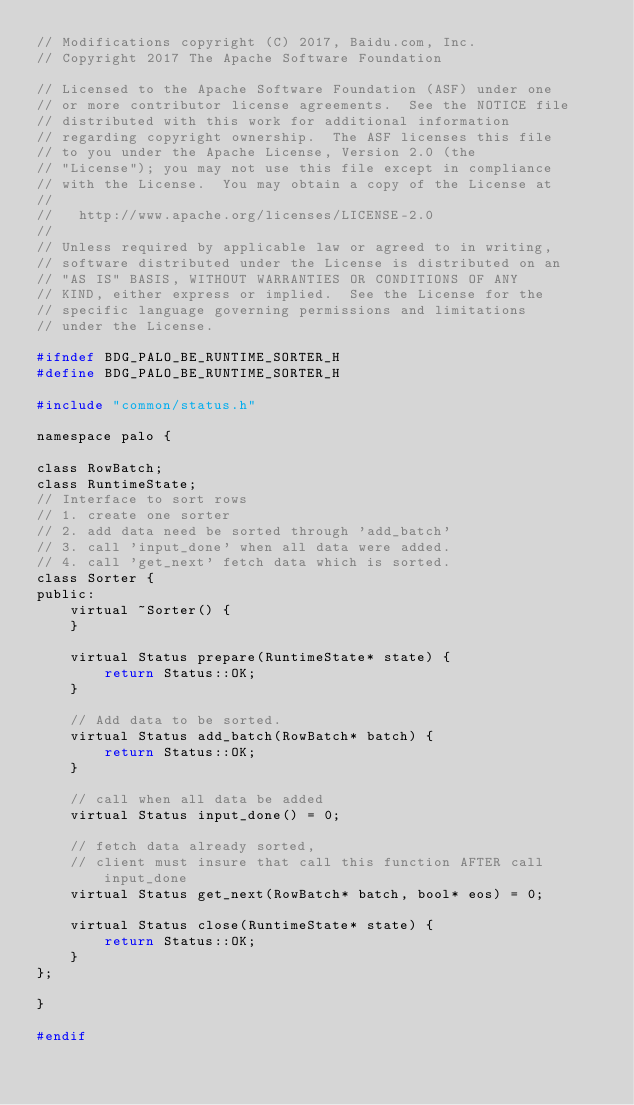<code> <loc_0><loc_0><loc_500><loc_500><_C_>// Modifications copyright (C) 2017, Baidu.com, Inc.
// Copyright 2017 The Apache Software Foundation

// Licensed to the Apache Software Foundation (ASF) under one
// or more contributor license agreements.  See the NOTICE file
// distributed with this work for additional information
// regarding copyright ownership.  The ASF licenses this file
// to you under the Apache License, Version 2.0 (the
// "License"); you may not use this file except in compliance
// with the License.  You may obtain a copy of the License at
//
//   http://www.apache.org/licenses/LICENSE-2.0
//
// Unless required by applicable law or agreed to in writing,
// software distributed under the License is distributed on an
// "AS IS" BASIS, WITHOUT WARRANTIES OR CONDITIONS OF ANY
// KIND, either express or implied.  See the License for the
// specific language governing permissions and limitations
// under the License.

#ifndef BDG_PALO_BE_RUNTIME_SORTER_H
#define BDG_PALO_BE_RUNTIME_SORTER_H

#include "common/status.h"

namespace palo {

class RowBatch;
class RuntimeState;
// Interface to sort rows
// 1. create one sorter
// 2. add data need be sorted through 'add_batch'
// 3. call 'input_done' when all data were added.
// 4. call 'get_next' fetch data which is sorted.
class Sorter {
public:
    virtual ~Sorter() { 
    }

    virtual Status prepare(RuntimeState* state) {
        return Status::OK;
    }

    // Add data to be sorted.
    virtual Status add_batch(RowBatch* batch) {
        return Status::OK;
    }

    // call when all data be added
    virtual Status input_done() = 0;

    // fetch data already sorted, 
    // client must insure that call this function AFTER call input_done
    virtual Status get_next(RowBatch* batch, bool* eos) = 0;

    virtual Status close(RuntimeState* state) {
        return Status::OK;
    }
};

}

#endif
</code> 